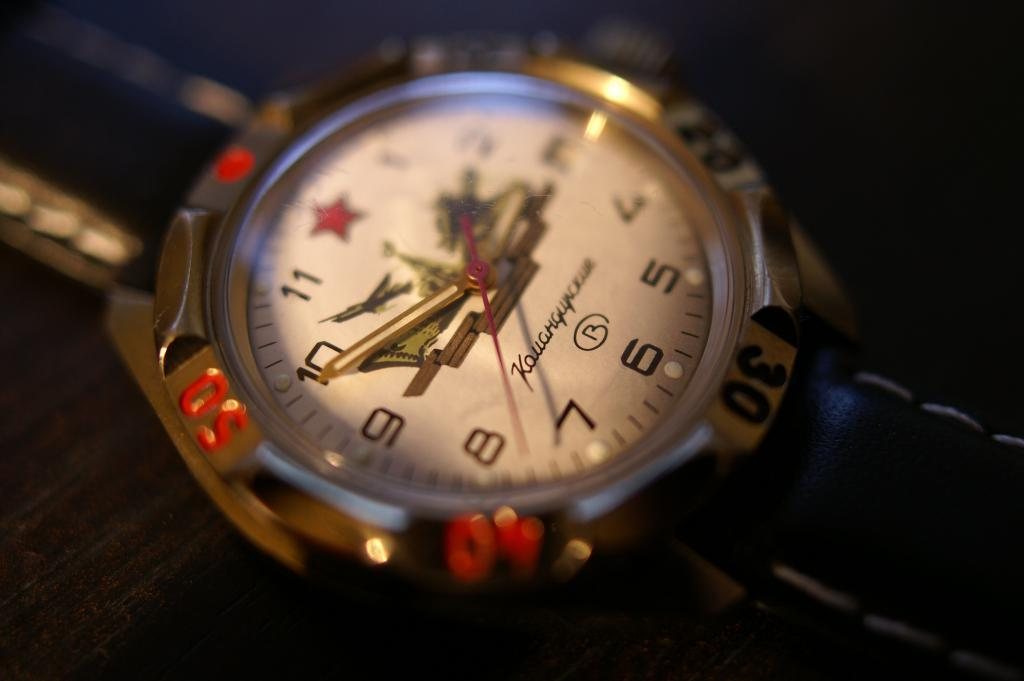<image>
Share a concise interpretation of the image provided. A wrist watch with a gold trim showing the time to be 2:49. 